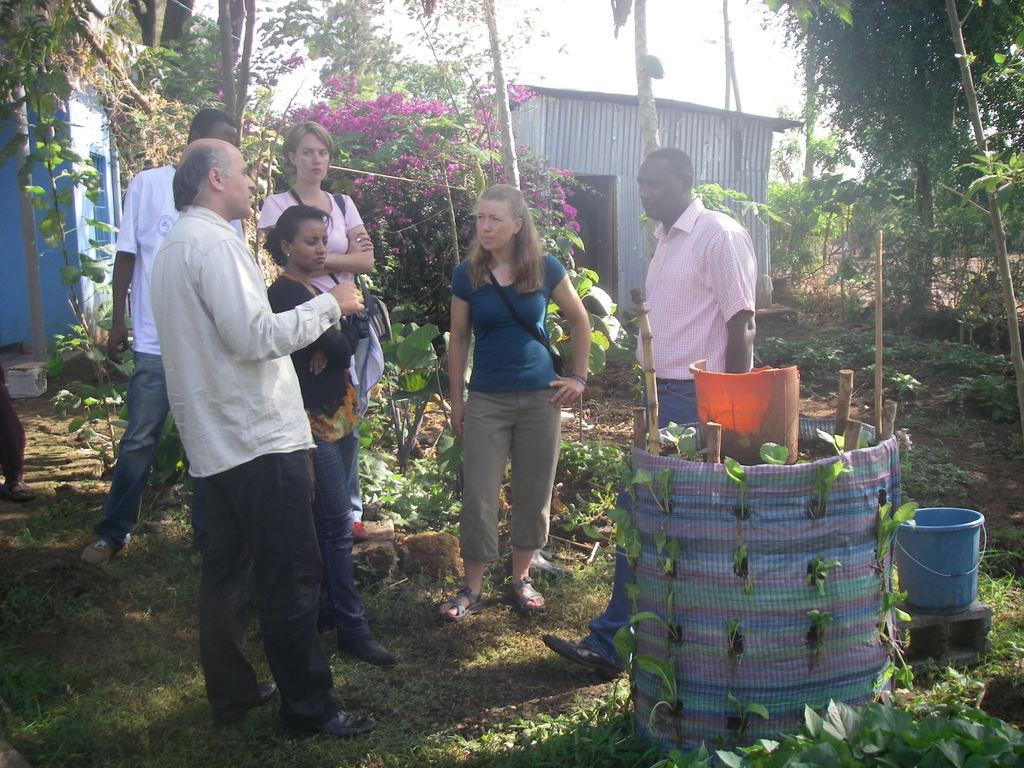Who or what can be seen in the image? There are people in the image. Where are the people located in the image? The people are standing in the center of the image. What can be observed in the surroundings of the people? There is greenery around the area of the image. What type of news is being reported by the wren in the image? There is no wren present in the image, and therefore no news is being reported. 